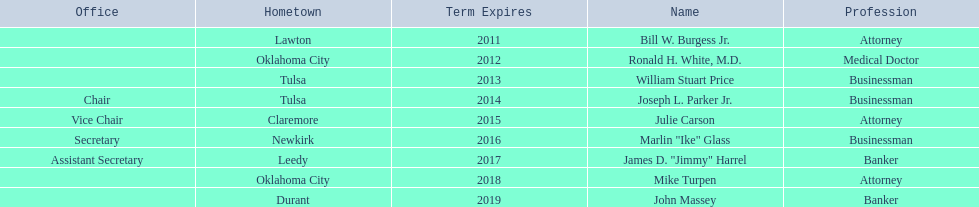How many of the current state regents have a listed office title? 4. 